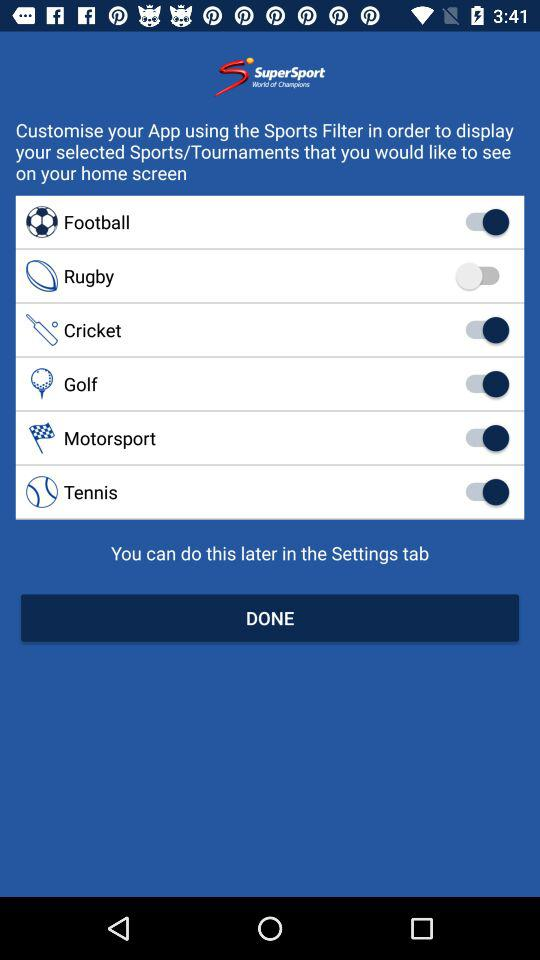What is the status of "Cricket"? The status is "on". 